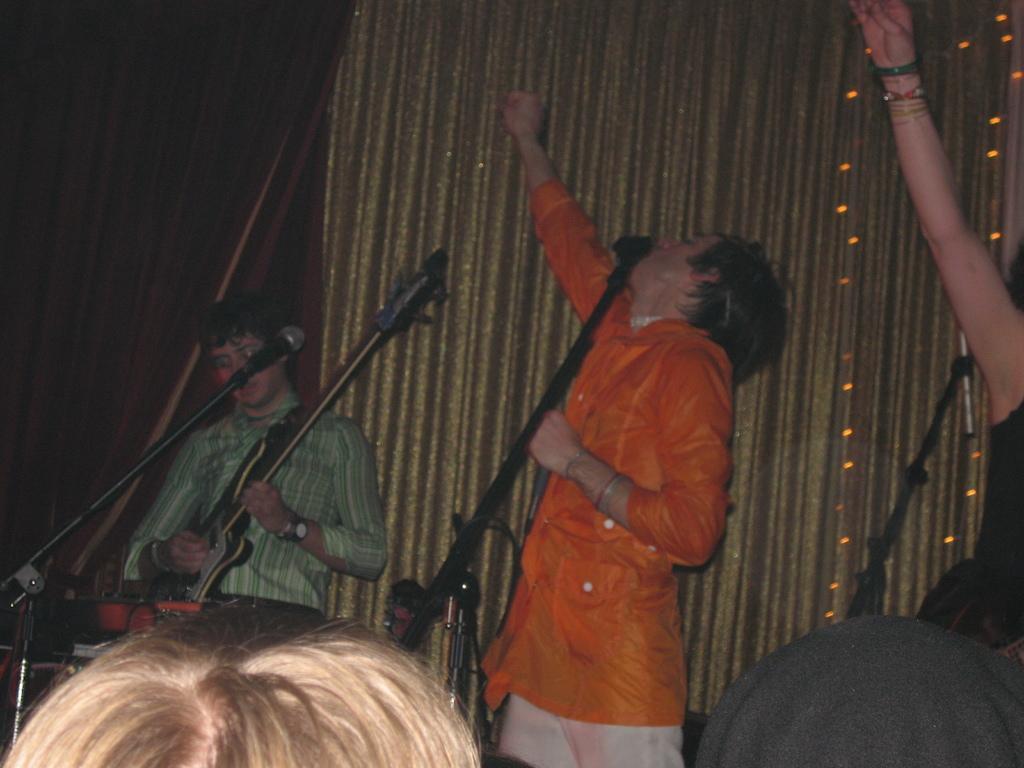Can you describe this image briefly? In this picture there are people and there is a man playing a guitar. We can see microphones with stands. In the background of the image we can see curtains and lights. At the bottom of the image we can see heads of persons. 